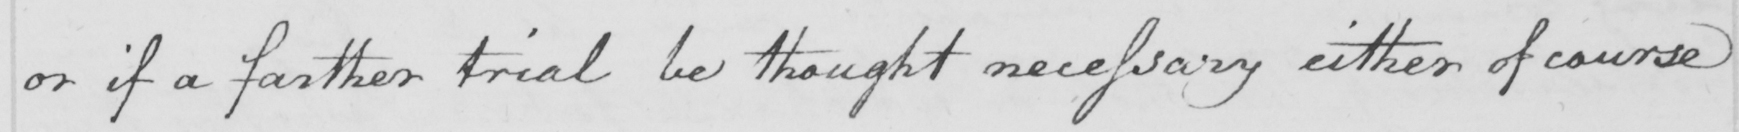What does this handwritten line say? or if a farther trial be thought necessary either of course 